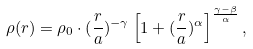Convert formula to latex. <formula><loc_0><loc_0><loc_500><loc_500>\rho ( r ) = \rho _ { 0 } \cdot ( \frac { r } { a } ) ^ { - \gamma } \left [ 1 + ( \frac { r } { a } ) ^ { \alpha } \right ] ^ { \frac { \gamma - \beta } { \alpha } } ,</formula> 